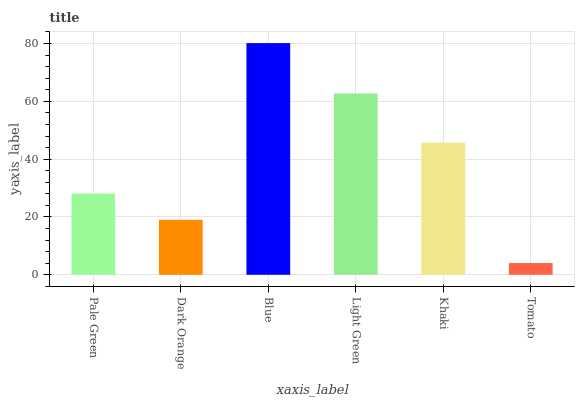Is Dark Orange the minimum?
Answer yes or no. No. Is Dark Orange the maximum?
Answer yes or no. No. Is Pale Green greater than Dark Orange?
Answer yes or no. Yes. Is Dark Orange less than Pale Green?
Answer yes or no. Yes. Is Dark Orange greater than Pale Green?
Answer yes or no. No. Is Pale Green less than Dark Orange?
Answer yes or no. No. Is Khaki the high median?
Answer yes or no. Yes. Is Pale Green the low median?
Answer yes or no. Yes. Is Dark Orange the high median?
Answer yes or no. No. Is Khaki the low median?
Answer yes or no. No. 